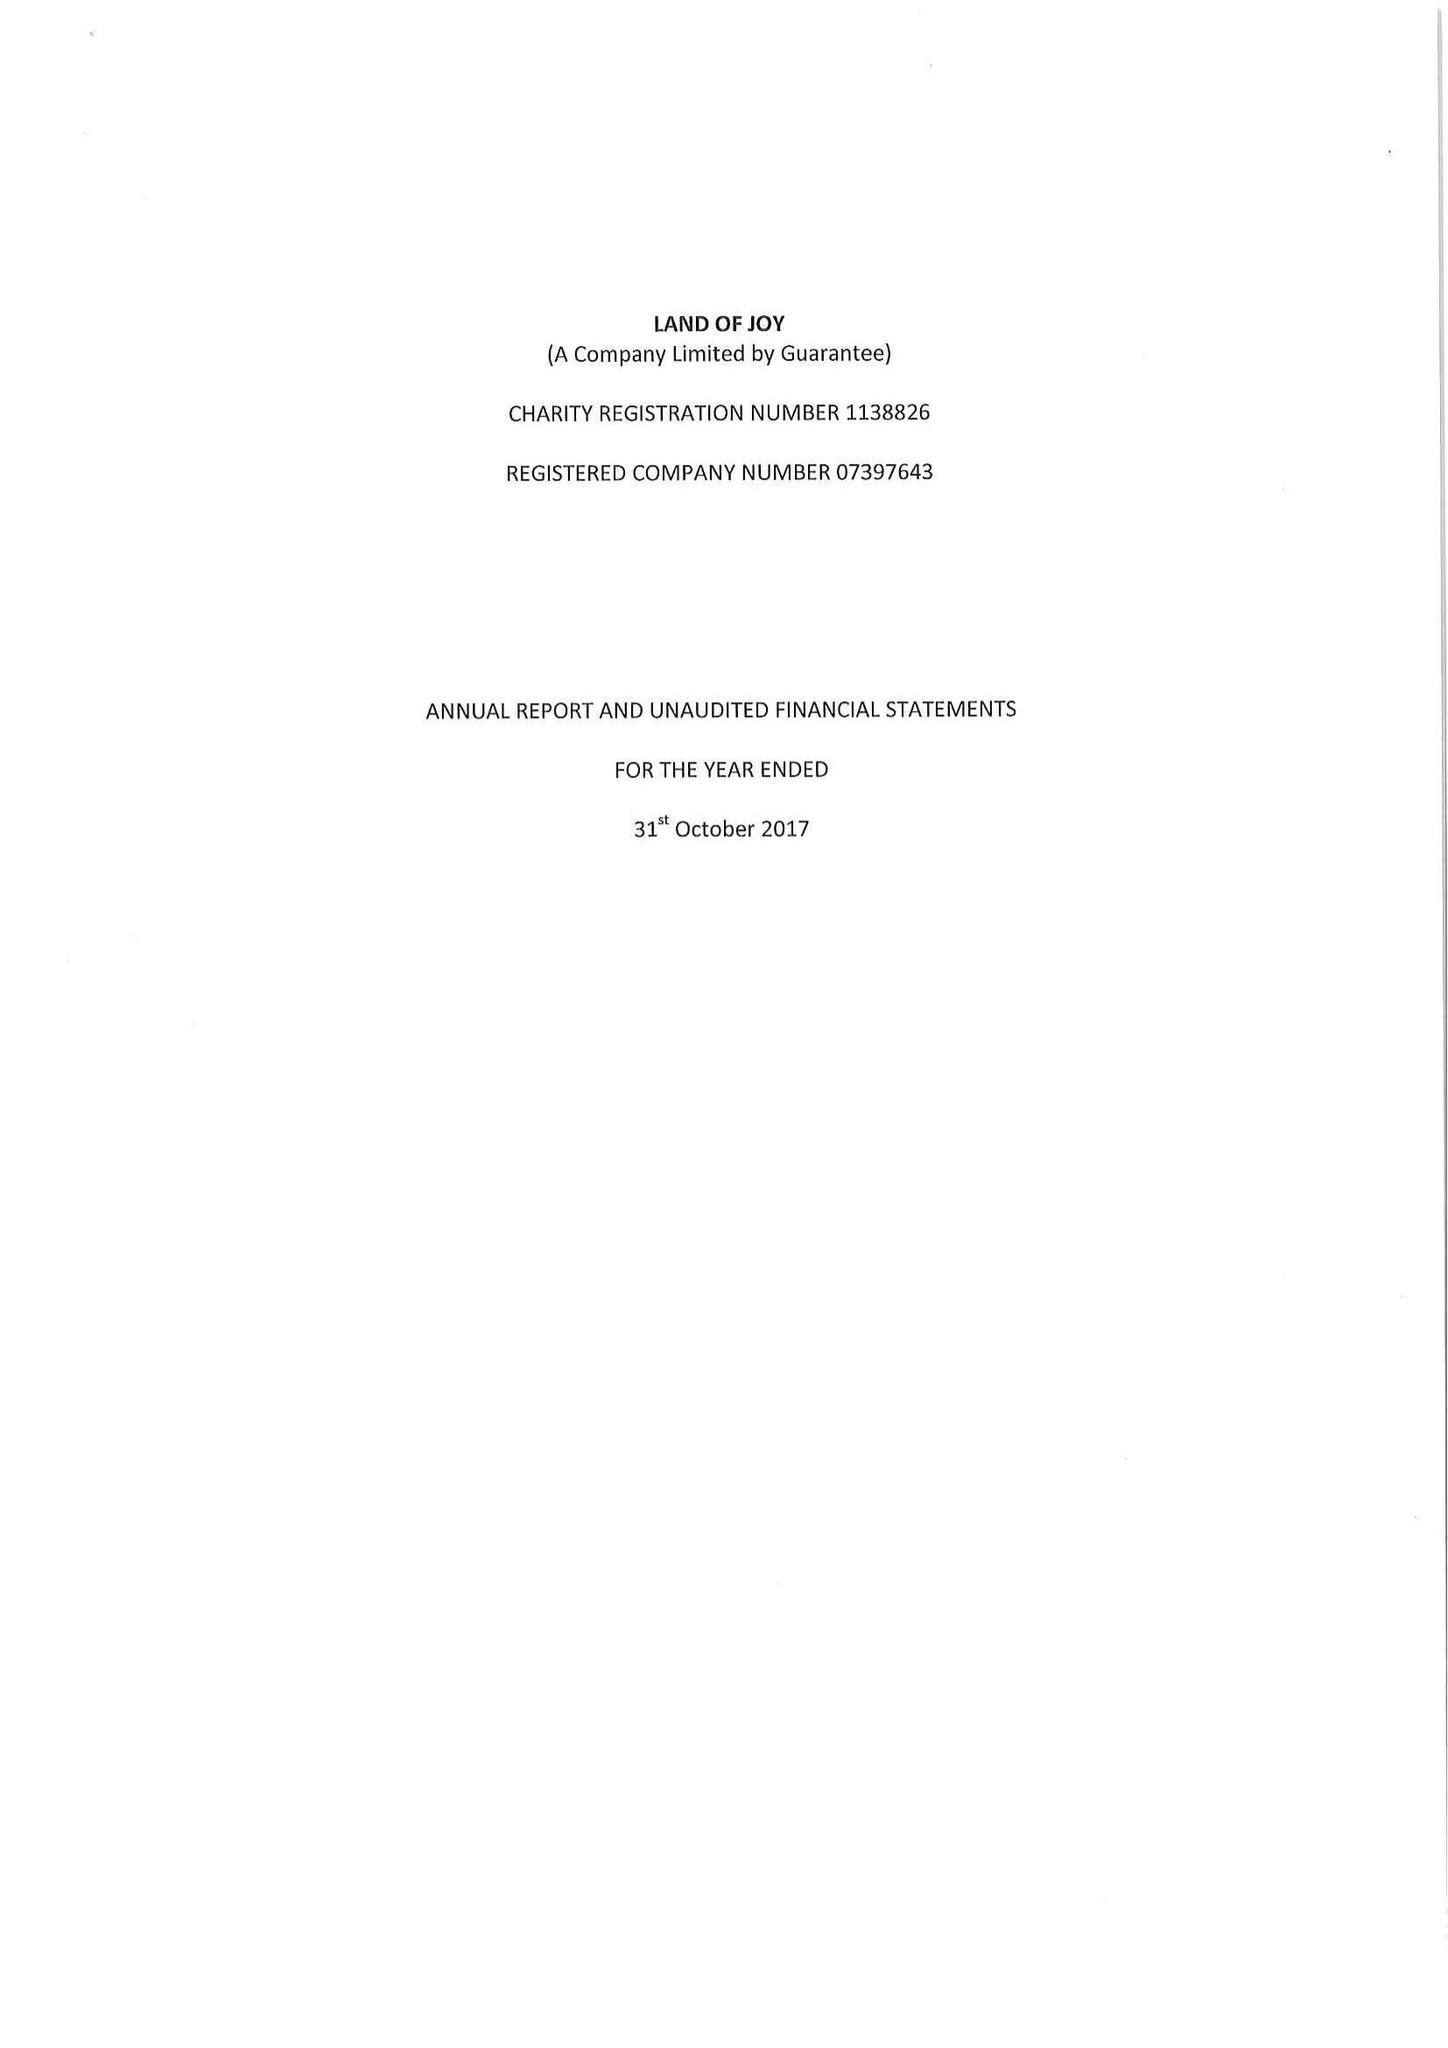What is the value for the charity_name?
Answer the question using a single word or phrase. Land Of Joy 